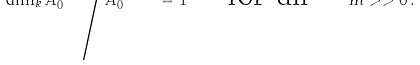Convert formula to latex. <formula><loc_0><loc_0><loc_500><loc_500>\dim _ { k } A _ { 0 } ^ { ( r m ) } \Big / A _ { 0 } ^ { ( r m - r ) } = 1 \quad \text { for all } \quad m > > 0 \, .</formula> 